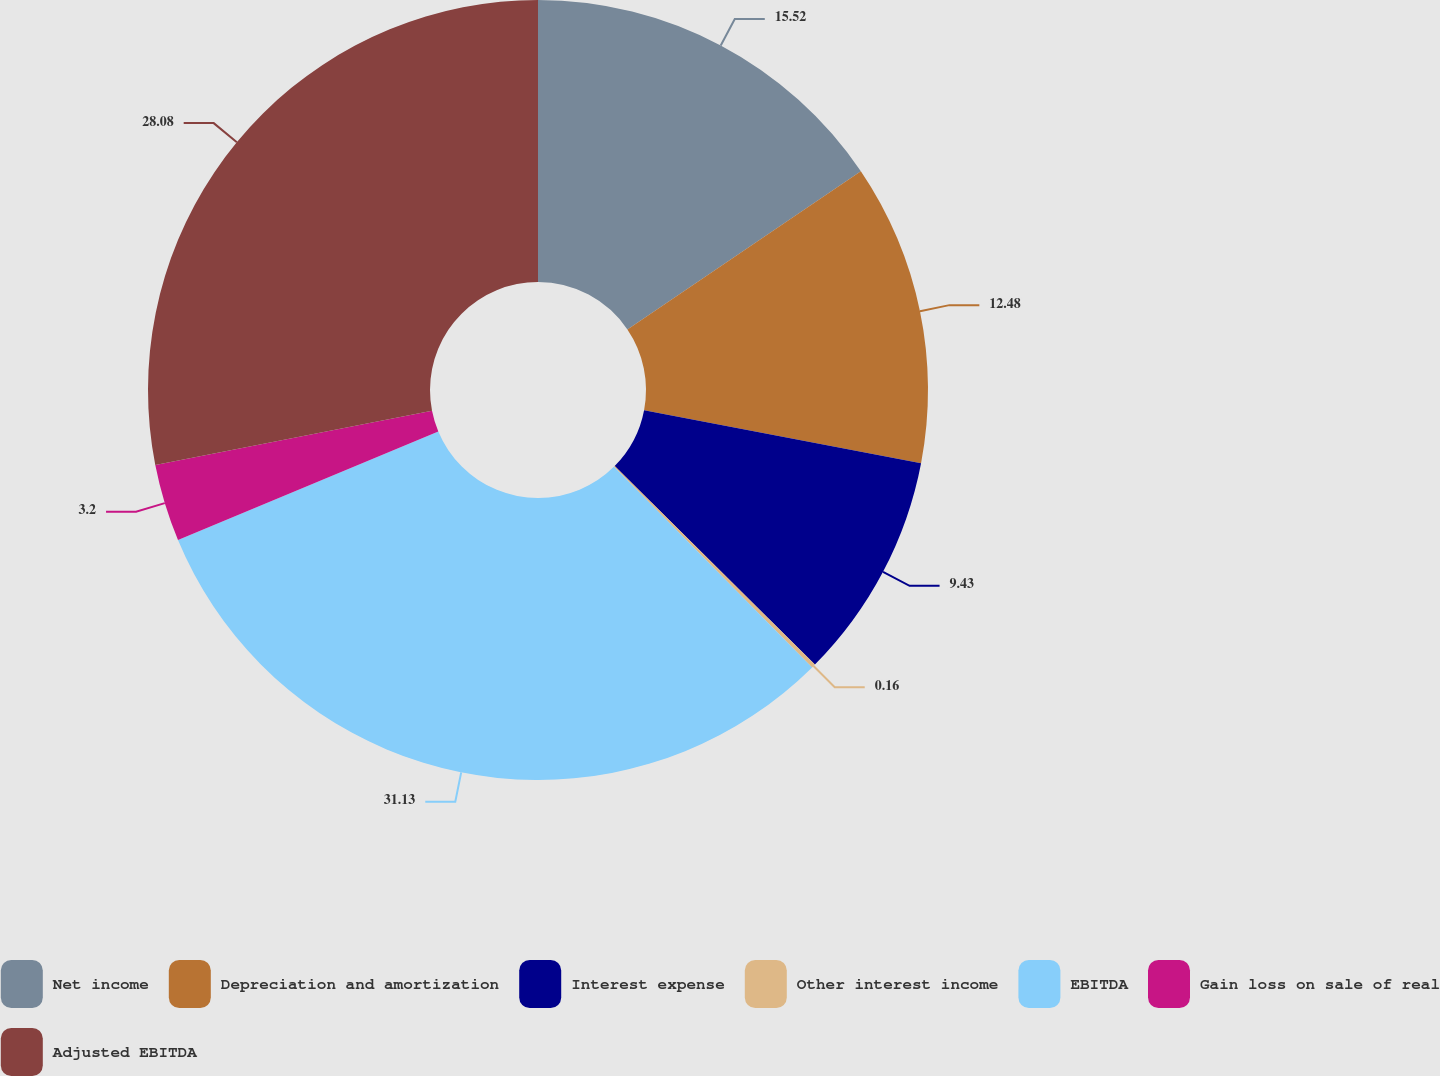Convert chart. <chart><loc_0><loc_0><loc_500><loc_500><pie_chart><fcel>Net income<fcel>Depreciation and amortization<fcel>Interest expense<fcel>Other interest income<fcel>EBITDA<fcel>Gain loss on sale of real<fcel>Adjusted EBITDA<nl><fcel>15.52%<fcel>12.48%<fcel>9.43%<fcel>0.16%<fcel>31.12%<fcel>3.2%<fcel>28.08%<nl></chart> 